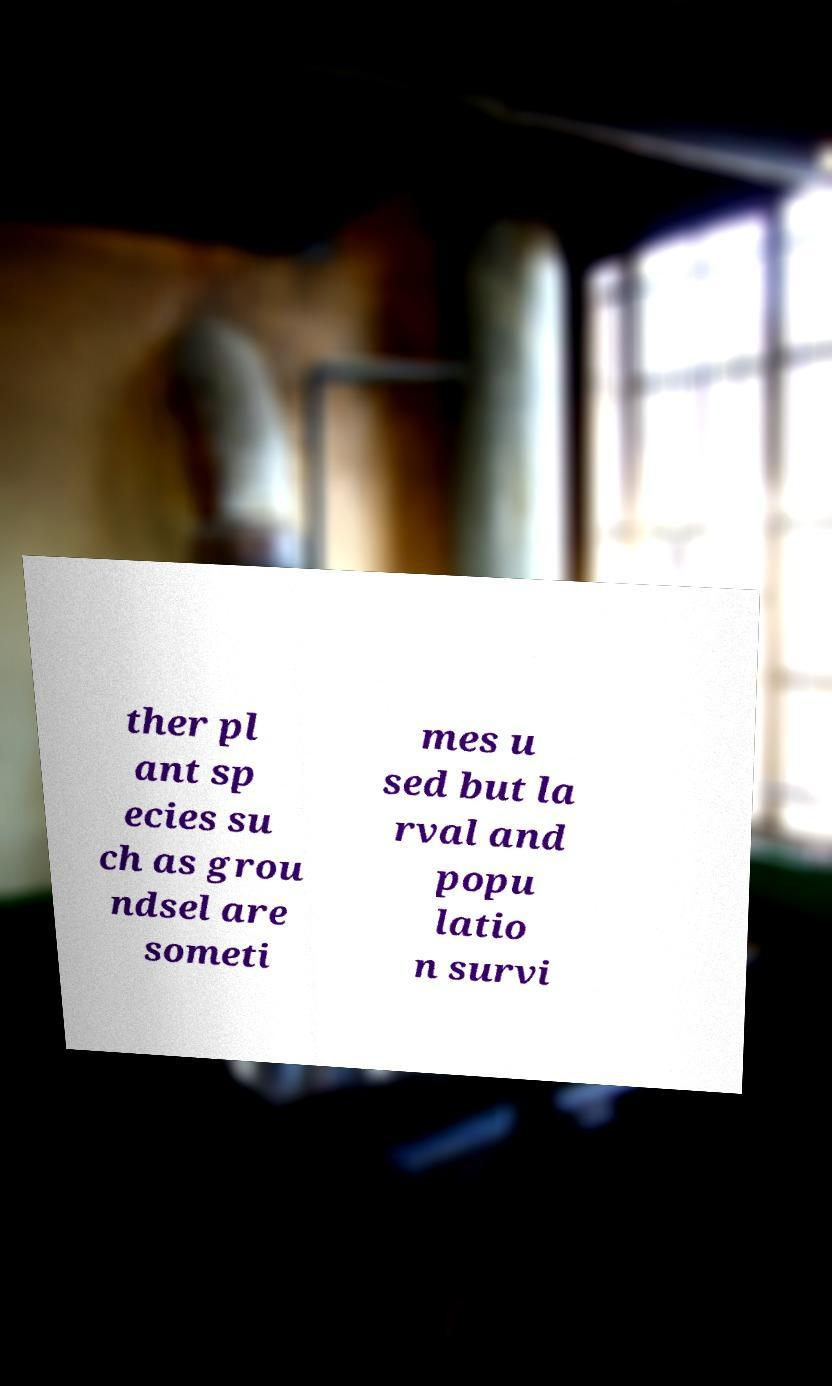Could you assist in decoding the text presented in this image and type it out clearly? ther pl ant sp ecies su ch as grou ndsel are someti mes u sed but la rval and popu latio n survi 